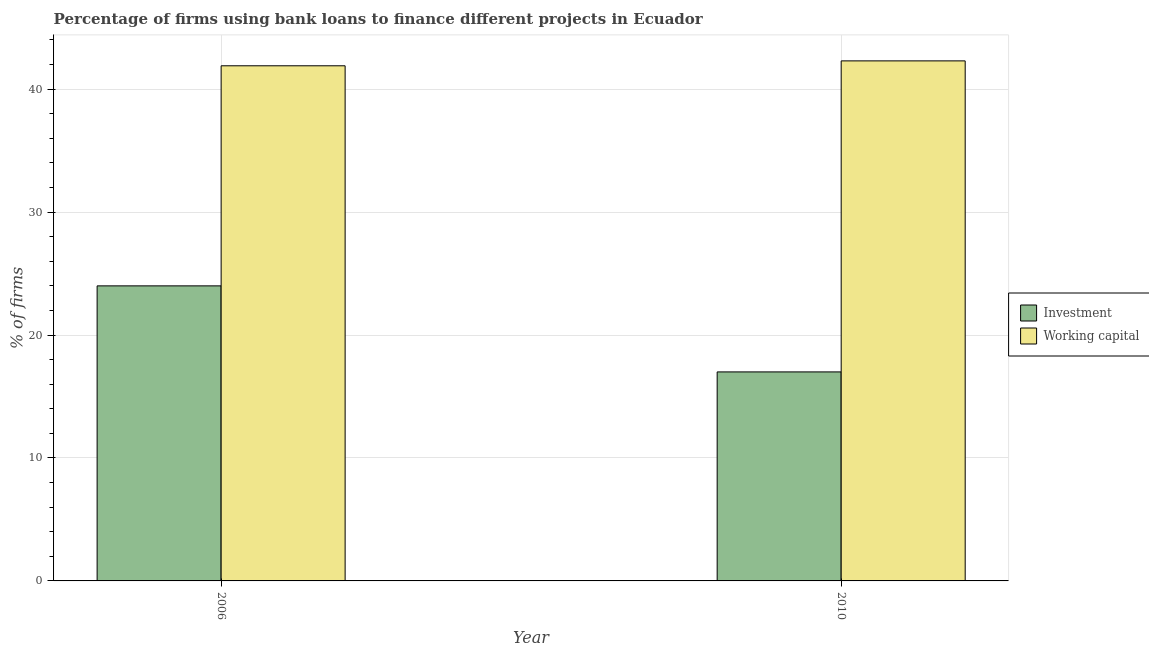How many groups of bars are there?
Provide a short and direct response. 2. How many bars are there on the 1st tick from the left?
Ensure brevity in your answer.  2. How many bars are there on the 1st tick from the right?
Offer a very short reply. 2. What is the label of the 2nd group of bars from the left?
Give a very brief answer. 2010. In how many cases, is the number of bars for a given year not equal to the number of legend labels?
Provide a succinct answer. 0. What is the percentage of firms using banks to finance investment in 2010?
Ensure brevity in your answer.  17. Across all years, what is the maximum percentage of firms using banks to finance working capital?
Your answer should be very brief. 42.3. Across all years, what is the minimum percentage of firms using banks to finance investment?
Your response must be concise. 17. In which year was the percentage of firms using banks to finance investment minimum?
Keep it short and to the point. 2010. What is the total percentage of firms using banks to finance working capital in the graph?
Your answer should be very brief. 84.2. What is the difference between the percentage of firms using banks to finance working capital in 2006 and that in 2010?
Offer a very short reply. -0.4. What is the difference between the percentage of firms using banks to finance investment in 2010 and the percentage of firms using banks to finance working capital in 2006?
Give a very brief answer. -7. What is the average percentage of firms using banks to finance investment per year?
Offer a terse response. 20.5. In the year 2010, what is the difference between the percentage of firms using banks to finance investment and percentage of firms using banks to finance working capital?
Give a very brief answer. 0. In how many years, is the percentage of firms using banks to finance investment greater than 4 %?
Ensure brevity in your answer.  2. What is the ratio of the percentage of firms using banks to finance investment in 2006 to that in 2010?
Provide a succinct answer. 1.41. Is the percentage of firms using banks to finance investment in 2006 less than that in 2010?
Provide a succinct answer. No. What does the 1st bar from the left in 2010 represents?
Your answer should be very brief. Investment. What does the 1st bar from the right in 2010 represents?
Give a very brief answer. Working capital. Are all the bars in the graph horizontal?
Make the answer very short. No. How many years are there in the graph?
Your answer should be compact. 2. What is the difference between two consecutive major ticks on the Y-axis?
Offer a very short reply. 10. Does the graph contain any zero values?
Offer a terse response. No. How many legend labels are there?
Offer a very short reply. 2. How are the legend labels stacked?
Provide a succinct answer. Vertical. What is the title of the graph?
Keep it short and to the point. Percentage of firms using bank loans to finance different projects in Ecuador. What is the label or title of the X-axis?
Keep it short and to the point. Year. What is the label or title of the Y-axis?
Offer a very short reply. % of firms. What is the % of firms of Investment in 2006?
Provide a succinct answer. 24. What is the % of firms of Working capital in 2006?
Your answer should be very brief. 41.9. What is the % of firms in Investment in 2010?
Ensure brevity in your answer.  17. What is the % of firms in Working capital in 2010?
Offer a terse response. 42.3. Across all years, what is the maximum % of firms in Investment?
Give a very brief answer. 24. Across all years, what is the maximum % of firms in Working capital?
Your response must be concise. 42.3. Across all years, what is the minimum % of firms of Working capital?
Give a very brief answer. 41.9. What is the total % of firms of Investment in the graph?
Your answer should be very brief. 41. What is the total % of firms of Working capital in the graph?
Give a very brief answer. 84.2. What is the difference between the % of firms of Investment in 2006 and that in 2010?
Keep it short and to the point. 7. What is the difference between the % of firms of Working capital in 2006 and that in 2010?
Keep it short and to the point. -0.4. What is the difference between the % of firms of Investment in 2006 and the % of firms of Working capital in 2010?
Your answer should be very brief. -18.3. What is the average % of firms in Investment per year?
Your answer should be very brief. 20.5. What is the average % of firms in Working capital per year?
Keep it short and to the point. 42.1. In the year 2006, what is the difference between the % of firms of Investment and % of firms of Working capital?
Your answer should be very brief. -17.9. In the year 2010, what is the difference between the % of firms in Investment and % of firms in Working capital?
Ensure brevity in your answer.  -25.3. What is the ratio of the % of firms in Investment in 2006 to that in 2010?
Ensure brevity in your answer.  1.41. What is the difference between the highest and the second highest % of firms of Investment?
Your answer should be very brief. 7. 